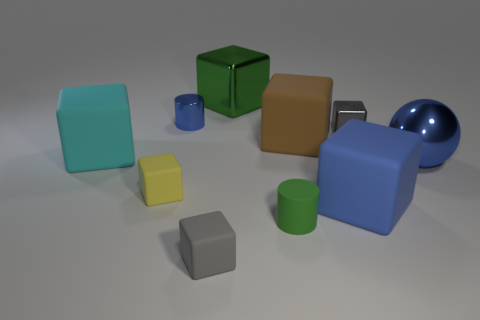What is the shape of the tiny thing that is both to the left of the small gray rubber block and in front of the tiny gray shiny thing?
Your answer should be compact. Cube. Is there another large object that has the same shape as the brown rubber thing?
Your response must be concise. Yes. What is the shape of the other blue object that is the same size as the blue rubber thing?
Ensure brevity in your answer.  Sphere. What is the material of the blue ball?
Your answer should be very brief. Metal. What size is the thing right of the tiny gray thing that is behind the tiny matte thing that is on the left side of the blue shiny cylinder?
Provide a succinct answer. Large. What is the material of the cylinder that is the same color as the large shiny sphere?
Make the answer very short. Metal. What number of matte objects are either small green cylinders or gray things?
Provide a short and direct response. 2. How big is the brown object?
Your answer should be very brief. Large. What number of things are cyan matte things or matte cubes that are on the right side of the large brown matte thing?
Give a very brief answer. 2. What number of other objects are there of the same color as the big sphere?
Your answer should be very brief. 2. 